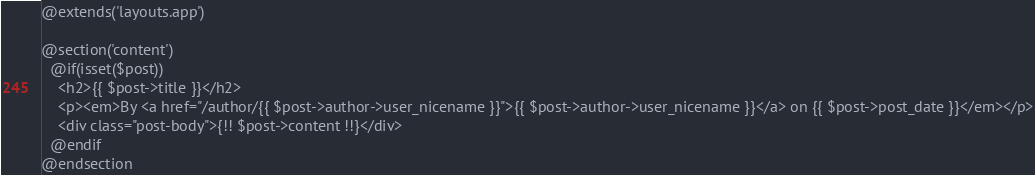Convert code to text. <code><loc_0><loc_0><loc_500><loc_500><_PHP_>@extends('layouts.app')

@section('content')
  @if(isset($post))
    <h2>{{ $post->title }}</h2>
    <p><em>By <a href="/author/{{ $post->author->user_nicename }}">{{ $post->author->user_nicename }}</a> on {{ $post->post_date }}</em></p>
    <div class="post-body">{!! $post->content !!}</div>
  @endif
@endsection
</code> 